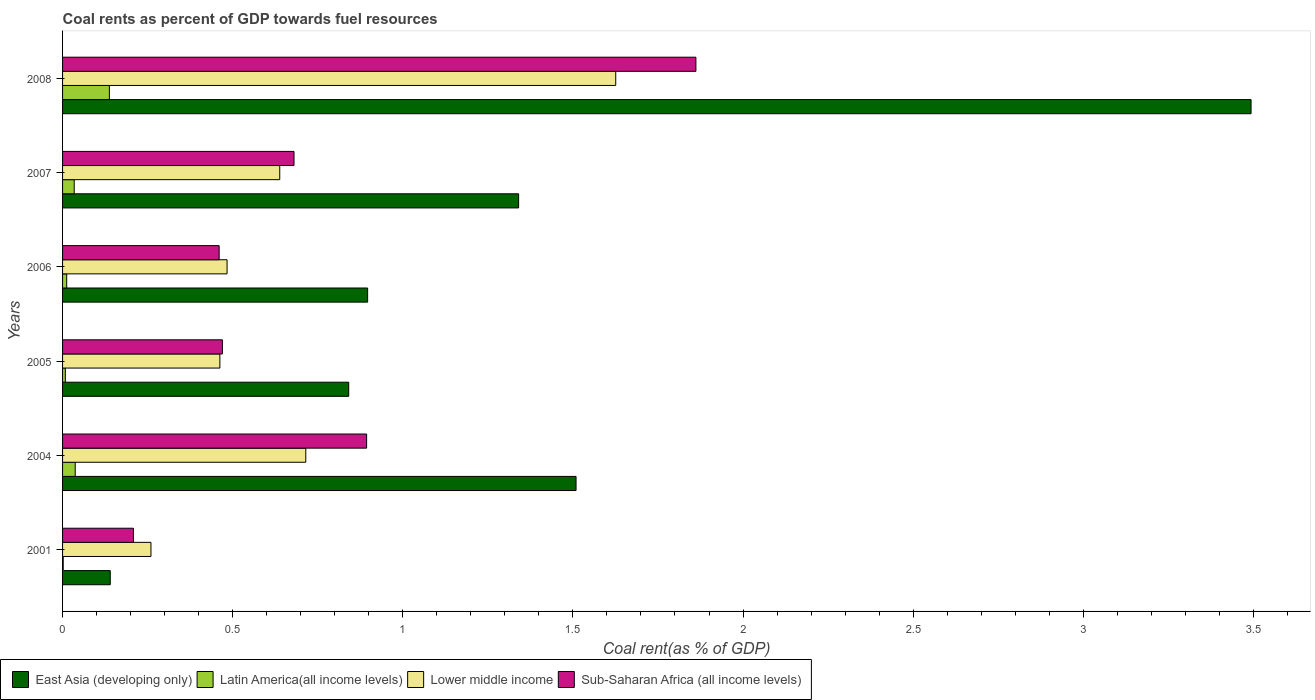How many different coloured bars are there?
Make the answer very short. 4. Are the number of bars per tick equal to the number of legend labels?
Offer a terse response. Yes. How many bars are there on the 4th tick from the bottom?
Offer a very short reply. 4. What is the label of the 3rd group of bars from the top?
Keep it short and to the point. 2006. What is the coal rent in Sub-Saharan Africa (all income levels) in 2008?
Ensure brevity in your answer.  1.86. Across all years, what is the maximum coal rent in East Asia (developing only)?
Keep it short and to the point. 3.49. Across all years, what is the minimum coal rent in Latin America(all income levels)?
Provide a short and direct response. 0. In which year was the coal rent in Lower middle income maximum?
Give a very brief answer. 2008. In which year was the coal rent in East Asia (developing only) minimum?
Offer a terse response. 2001. What is the total coal rent in Lower middle income in the graph?
Make the answer very short. 4.18. What is the difference between the coal rent in Lower middle income in 2004 and that in 2006?
Make the answer very short. 0.23. What is the difference between the coal rent in Lower middle income in 2008 and the coal rent in Latin America(all income levels) in 2007?
Make the answer very short. 1.59. What is the average coal rent in Lower middle income per year?
Offer a very short reply. 0.7. In the year 2006, what is the difference between the coal rent in East Asia (developing only) and coal rent in Latin America(all income levels)?
Give a very brief answer. 0.88. What is the ratio of the coal rent in Latin America(all income levels) in 2004 to that in 2005?
Keep it short and to the point. 4.54. Is the difference between the coal rent in East Asia (developing only) in 2001 and 2006 greater than the difference between the coal rent in Latin America(all income levels) in 2001 and 2006?
Your answer should be compact. No. What is the difference between the highest and the second highest coal rent in East Asia (developing only)?
Your answer should be very brief. 1.98. What is the difference between the highest and the lowest coal rent in Latin America(all income levels)?
Offer a terse response. 0.14. Is it the case that in every year, the sum of the coal rent in Sub-Saharan Africa (all income levels) and coal rent in East Asia (developing only) is greater than the sum of coal rent in Lower middle income and coal rent in Latin America(all income levels)?
Offer a terse response. Yes. What does the 1st bar from the top in 2005 represents?
Provide a short and direct response. Sub-Saharan Africa (all income levels). What does the 2nd bar from the bottom in 2007 represents?
Keep it short and to the point. Latin America(all income levels). How many bars are there?
Offer a terse response. 24. Are all the bars in the graph horizontal?
Your answer should be compact. Yes. Are the values on the major ticks of X-axis written in scientific E-notation?
Ensure brevity in your answer.  No. Does the graph contain any zero values?
Make the answer very short. No. Does the graph contain grids?
Make the answer very short. No. What is the title of the graph?
Give a very brief answer. Coal rents as percent of GDP towards fuel resources. What is the label or title of the X-axis?
Offer a very short reply. Coal rent(as % of GDP). What is the label or title of the Y-axis?
Make the answer very short. Years. What is the Coal rent(as % of GDP) of East Asia (developing only) in 2001?
Offer a very short reply. 0.14. What is the Coal rent(as % of GDP) of Latin America(all income levels) in 2001?
Provide a succinct answer. 0. What is the Coal rent(as % of GDP) in Lower middle income in 2001?
Your answer should be very brief. 0.26. What is the Coal rent(as % of GDP) in Sub-Saharan Africa (all income levels) in 2001?
Your answer should be compact. 0.21. What is the Coal rent(as % of GDP) in East Asia (developing only) in 2004?
Make the answer very short. 1.51. What is the Coal rent(as % of GDP) in Latin America(all income levels) in 2004?
Provide a short and direct response. 0.04. What is the Coal rent(as % of GDP) of Lower middle income in 2004?
Offer a terse response. 0.71. What is the Coal rent(as % of GDP) of Sub-Saharan Africa (all income levels) in 2004?
Your answer should be very brief. 0.89. What is the Coal rent(as % of GDP) in East Asia (developing only) in 2005?
Give a very brief answer. 0.84. What is the Coal rent(as % of GDP) of Latin America(all income levels) in 2005?
Provide a short and direct response. 0.01. What is the Coal rent(as % of GDP) of Lower middle income in 2005?
Give a very brief answer. 0.46. What is the Coal rent(as % of GDP) in Sub-Saharan Africa (all income levels) in 2005?
Your answer should be compact. 0.47. What is the Coal rent(as % of GDP) of East Asia (developing only) in 2006?
Ensure brevity in your answer.  0.9. What is the Coal rent(as % of GDP) in Latin America(all income levels) in 2006?
Offer a very short reply. 0.01. What is the Coal rent(as % of GDP) of Lower middle income in 2006?
Provide a short and direct response. 0.48. What is the Coal rent(as % of GDP) in Sub-Saharan Africa (all income levels) in 2006?
Provide a succinct answer. 0.46. What is the Coal rent(as % of GDP) of East Asia (developing only) in 2007?
Provide a succinct answer. 1.34. What is the Coal rent(as % of GDP) of Latin America(all income levels) in 2007?
Your answer should be very brief. 0.03. What is the Coal rent(as % of GDP) in Lower middle income in 2007?
Provide a short and direct response. 0.64. What is the Coal rent(as % of GDP) of Sub-Saharan Africa (all income levels) in 2007?
Your answer should be very brief. 0.68. What is the Coal rent(as % of GDP) in East Asia (developing only) in 2008?
Ensure brevity in your answer.  3.49. What is the Coal rent(as % of GDP) of Latin America(all income levels) in 2008?
Offer a terse response. 0.14. What is the Coal rent(as % of GDP) of Lower middle income in 2008?
Provide a succinct answer. 1.63. What is the Coal rent(as % of GDP) in Sub-Saharan Africa (all income levels) in 2008?
Your answer should be very brief. 1.86. Across all years, what is the maximum Coal rent(as % of GDP) in East Asia (developing only)?
Offer a terse response. 3.49. Across all years, what is the maximum Coal rent(as % of GDP) in Latin America(all income levels)?
Offer a terse response. 0.14. Across all years, what is the maximum Coal rent(as % of GDP) of Lower middle income?
Give a very brief answer. 1.63. Across all years, what is the maximum Coal rent(as % of GDP) in Sub-Saharan Africa (all income levels)?
Provide a succinct answer. 1.86. Across all years, what is the minimum Coal rent(as % of GDP) of East Asia (developing only)?
Your response must be concise. 0.14. Across all years, what is the minimum Coal rent(as % of GDP) of Latin America(all income levels)?
Offer a very short reply. 0. Across all years, what is the minimum Coal rent(as % of GDP) in Lower middle income?
Give a very brief answer. 0.26. Across all years, what is the minimum Coal rent(as % of GDP) in Sub-Saharan Africa (all income levels)?
Make the answer very short. 0.21. What is the total Coal rent(as % of GDP) of East Asia (developing only) in the graph?
Give a very brief answer. 8.22. What is the total Coal rent(as % of GDP) of Latin America(all income levels) in the graph?
Ensure brevity in your answer.  0.23. What is the total Coal rent(as % of GDP) of Lower middle income in the graph?
Offer a very short reply. 4.18. What is the total Coal rent(as % of GDP) in Sub-Saharan Africa (all income levels) in the graph?
Give a very brief answer. 4.57. What is the difference between the Coal rent(as % of GDP) of East Asia (developing only) in 2001 and that in 2004?
Ensure brevity in your answer.  -1.37. What is the difference between the Coal rent(as % of GDP) of Latin America(all income levels) in 2001 and that in 2004?
Keep it short and to the point. -0.04. What is the difference between the Coal rent(as % of GDP) in Lower middle income in 2001 and that in 2004?
Provide a short and direct response. -0.46. What is the difference between the Coal rent(as % of GDP) of Sub-Saharan Africa (all income levels) in 2001 and that in 2004?
Provide a short and direct response. -0.69. What is the difference between the Coal rent(as % of GDP) in East Asia (developing only) in 2001 and that in 2005?
Make the answer very short. -0.7. What is the difference between the Coal rent(as % of GDP) of Latin America(all income levels) in 2001 and that in 2005?
Ensure brevity in your answer.  -0.01. What is the difference between the Coal rent(as % of GDP) in Lower middle income in 2001 and that in 2005?
Provide a short and direct response. -0.2. What is the difference between the Coal rent(as % of GDP) in Sub-Saharan Africa (all income levels) in 2001 and that in 2005?
Offer a very short reply. -0.26. What is the difference between the Coal rent(as % of GDP) in East Asia (developing only) in 2001 and that in 2006?
Offer a very short reply. -0.76. What is the difference between the Coal rent(as % of GDP) in Latin America(all income levels) in 2001 and that in 2006?
Provide a succinct answer. -0.01. What is the difference between the Coal rent(as % of GDP) of Lower middle income in 2001 and that in 2006?
Offer a terse response. -0.22. What is the difference between the Coal rent(as % of GDP) in Sub-Saharan Africa (all income levels) in 2001 and that in 2006?
Keep it short and to the point. -0.25. What is the difference between the Coal rent(as % of GDP) in East Asia (developing only) in 2001 and that in 2007?
Ensure brevity in your answer.  -1.2. What is the difference between the Coal rent(as % of GDP) in Latin America(all income levels) in 2001 and that in 2007?
Keep it short and to the point. -0.03. What is the difference between the Coal rent(as % of GDP) of Lower middle income in 2001 and that in 2007?
Your answer should be very brief. -0.38. What is the difference between the Coal rent(as % of GDP) of Sub-Saharan Africa (all income levels) in 2001 and that in 2007?
Ensure brevity in your answer.  -0.47. What is the difference between the Coal rent(as % of GDP) in East Asia (developing only) in 2001 and that in 2008?
Ensure brevity in your answer.  -3.35. What is the difference between the Coal rent(as % of GDP) in Latin America(all income levels) in 2001 and that in 2008?
Provide a short and direct response. -0.14. What is the difference between the Coal rent(as % of GDP) of Lower middle income in 2001 and that in 2008?
Ensure brevity in your answer.  -1.37. What is the difference between the Coal rent(as % of GDP) of Sub-Saharan Africa (all income levels) in 2001 and that in 2008?
Your response must be concise. -1.65. What is the difference between the Coal rent(as % of GDP) of East Asia (developing only) in 2004 and that in 2005?
Your answer should be compact. 0.67. What is the difference between the Coal rent(as % of GDP) in Latin America(all income levels) in 2004 and that in 2005?
Offer a very short reply. 0.03. What is the difference between the Coal rent(as % of GDP) of Lower middle income in 2004 and that in 2005?
Offer a terse response. 0.25. What is the difference between the Coal rent(as % of GDP) of Sub-Saharan Africa (all income levels) in 2004 and that in 2005?
Ensure brevity in your answer.  0.42. What is the difference between the Coal rent(as % of GDP) of East Asia (developing only) in 2004 and that in 2006?
Make the answer very short. 0.61. What is the difference between the Coal rent(as % of GDP) of Latin America(all income levels) in 2004 and that in 2006?
Make the answer very short. 0.03. What is the difference between the Coal rent(as % of GDP) of Lower middle income in 2004 and that in 2006?
Provide a short and direct response. 0.23. What is the difference between the Coal rent(as % of GDP) of Sub-Saharan Africa (all income levels) in 2004 and that in 2006?
Your response must be concise. 0.43. What is the difference between the Coal rent(as % of GDP) of East Asia (developing only) in 2004 and that in 2007?
Your answer should be very brief. 0.17. What is the difference between the Coal rent(as % of GDP) in Latin America(all income levels) in 2004 and that in 2007?
Your answer should be very brief. 0. What is the difference between the Coal rent(as % of GDP) in Lower middle income in 2004 and that in 2007?
Make the answer very short. 0.08. What is the difference between the Coal rent(as % of GDP) of Sub-Saharan Africa (all income levels) in 2004 and that in 2007?
Your answer should be compact. 0.21. What is the difference between the Coal rent(as % of GDP) in East Asia (developing only) in 2004 and that in 2008?
Keep it short and to the point. -1.98. What is the difference between the Coal rent(as % of GDP) of Latin America(all income levels) in 2004 and that in 2008?
Give a very brief answer. -0.1. What is the difference between the Coal rent(as % of GDP) in Lower middle income in 2004 and that in 2008?
Your response must be concise. -0.91. What is the difference between the Coal rent(as % of GDP) of Sub-Saharan Africa (all income levels) in 2004 and that in 2008?
Offer a terse response. -0.97. What is the difference between the Coal rent(as % of GDP) in East Asia (developing only) in 2005 and that in 2006?
Your answer should be very brief. -0.06. What is the difference between the Coal rent(as % of GDP) in Latin America(all income levels) in 2005 and that in 2006?
Offer a very short reply. -0. What is the difference between the Coal rent(as % of GDP) in Lower middle income in 2005 and that in 2006?
Your answer should be very brief. -0.02. What is the difference between the Coal rent(as % of GDP) of Sub-Saharan Africa (all income levels) in 2005 and that in 2006?
Your answer should be compact. 0.01. What is the difference between the Coal rent(as % of GDP) in East Asia (developing only) in 2005 and that in 2007?
Give a very brief answer. -0.5. What is the difference between the Coal rent(as % of GDP) in Latin America(all income levels) in 2005 and that in 2007?
Make the answer very short. -0.03. What is the difference between the Coal rent(as % of GDP) of Lower middle income in 2005 and that in 2007?
Keep it short and to the point. -0.18. What is the difference between the Coal rent(as % of GDP) of Sub-Saharan Africa (all income levels) in 2005 and that in 2007?
Keep it short and to the point. -0.21. What is the difference between the Coal rent(as % of GDP) in East Asia (developing only) in 2005 and that in 2008?
Make the answer very short. -2.65. What is the difference between the Coal rent(as % of GDP) in Latin America(all income levels) in 2005 and that in 2008?
Make the answer very short. -0.13. What is the difference between the Coal rent(as % of GDP) in Lower middle income in 2005 and that in 2008?
Keep it short and to the point. -1.16. What is the difference between the Coal rent(as % of GDP) in Sub-Saharan Africa (all income levels) in 2005 and that in 2008?
Your response must be concise. -1.39. What is the difference between the Coal rent(as % of GDP) of East Asia (developing only) in 2006 and that in 2007?
Offer a terse response. -0.44. What is the difference between the Coal rent(as % of GDP) in Latin America(all income levels) in 2006 and that in 2007?
Keep it short and to the point. -0.02. What is the difference between the Coal rent(as % of GDP) in Lower middle income in 2006 and that in 2007?
Your answer should be very brief. -0.15. What is the difference between the Coal rent(as % of GDP) of Sub-Saharan Africa (all income levels) in 2006 and that in 2007?
Your answer should be very brief. -0.22. What is the difference between the Coal rent(as % of GDP) of East Asia (developing only) in 2006 and that in 2008?
Provide a succinct answer. -2.6. What is the difference between the Coal rent(as % of GDP) in Latin America(all income levels) in 2006 and that in 2008?
Offer a terse response. -0.13. What is the difference between the Coal rent(as % of GDP) of Lower middle income in 2006 and that in 2008?
Make the answer very short. -1.14. What is the difference between the Coal rent(as % of GDP) of Sub-Saharan Africa (all income levels) in 2006 and that in 2008?
Give a very brief answer. -1.4. What is the difference between the Coal rent(as % of GDP) in East Asia (developing only) in 2007 and that in 2008?
Your response must be concise. -2.15. What is the difference between the Coal rent(as % of GDP) of Latin America(all income levels) in 2007 and that in 2008?
Provide a succinct answer. -0.1. What is the difference between the Coal rent(as % of GDP) in Lower middle income in 2007 and that in 2008?
Give a very brief answer. -0.99. What is the difference between the Coal rent(as % of GDP) of Sub-Saharan Africa (all income levels) in 2007 and that in 2008?
Ensure brevity in your answer.  -1.18. What is the difference between the Coal rent(as % of GDP) in East Asia (developing only) in 2001 and the Coal rent(as % of GDP) in Latin America(all income levels) in 2004?
Your answer should be very brief. 0.1. What is the difference between the Coal rent(as % of GDP) in East Asia (developing only) in 2001 and the Coal rent(as % of GDP) in Lower middle income in 2004?
Your response must be concise. -0.57. What is the difference between the Coal rent(as % of GDP) of East Asia (developing only) in 2001 and the Coal rent(as % of GDP) of Sub-Saharan Africa (all income levels) in 2004?
Your answer should be compact. -0.75. What is the difference between the Coal rent(as % of GDP) of Latin America(all income levels) in 2001 and the Coal rent(as % of GDP) of Lower middle income in 2004?
Keep it short and to the point. -0.71. What is the difference between the Coal rent(as % of GDP) of Latin America(all income levels) in 2001 and the Coal rent(as % of GDP) of Sub-Saharan Africa (all income levels) in 2004?
Your answer should be compact. -0.89. What is the difference between the Coal rent(as % of GDP) of Lower middle income in 2001 and the Coal rent(as % of GDP) of Sub-Saharan Africa (all income levels) in 2004?
Your response must be concise. -0.63. What is the difference between the Coal rent(as % of GDP) of East Asia (developing only) in 2001 and the Coal rent(as % of GDP) of Latin America(all income levels) in 2005?
Offer a very short reply. 0.13. What is the difference between the Coal rent(as % of GDP) of East Asia (developing only) in 2001 and the Coal rent(as % of GDP) of Lower middle income in 2005?
Your answer should be very brief. -0.32. What is the difference between the Coal rent(as % of GDP) of East Asia (developing only) in 2001 and the Coal rent(as % of GDP) of Sub-Saharan Africa (all income levels) in 2005?
Offer a terse response. -0.33. What is the difference between the Coal rent(as % of GDP) of Latin America(all income levels) in 2001 and the Coal rent(as % of GDP) of Lower middle income in 2005?
Provide a short and direct response. -0.46. What is the difference between the Coal rent(as % of GDP) in Latin America(all income levels) in 2001 and the Coal rent(as % of GDP) in Sub-Saharan Africa (all income levels) in 2005?
Offer a very short reply. -0.47. What is the difference between the Coal rent(as % of GDP) in Lower middle income in 2001 and the Coal rent(as % of GDP) in Sub-Saharan Africa (all income levels) in 2005?
Your answer should be compact. -0.21. What is the difference between the Coal rent(as % of GDP) in East Asia (developing only) in 2001 and the Coal rent(as % of GDP) in Latin America(all income levels) in 2006?
Ensure brevity in your answer.  0.13. What is the difference between the Coal rent(as % of GDP) in East Asia (developing only) in 2001 and the Coal rent(as % of GDP) in Lower middle income in 2006?
Your answer should be very brief. -0.34. What is the difference between the Coal rent(as % of GDP) in East Asia (developing only) in 2001 and the Coal rent(as % of GDP) in Sub-Saharan Africa (all income levels) in 2006?
Make the answer very short. -0.32. What is the difference between the Coal rent(as % of GDP) of Latin America(all income levels) in 2001 and the Coal rent(as % of GDP) of Lower middle income in 2006?
Your response must be concise. -0.48. What is the difference between the Coal rent(as % of GDP) of Latin America(all income levels) in 2001 and the Coal rent(as % of GDP) of Sub-Saharan Africa (all income levels) in 2006?
Provide a short and direct response. -0.46. What is the difference between the Coal rent(as % of GDP) in Lower middle income in 2001 and the Coal rent(as % of GDP) in Sub-Saharan Africa (all income levels) in 2006?
Offer a very short reply. -0.2. What is the difference between the Coal rent(as % of GDP) of East Asia (developing only) in 2001 and the Coal rent(as % of GDP) of Latin America(all income levels) in 2007?
Offer a very short reply. 0.11. What is the difference between the Coal rent(as % of GDP) of East Asia (developing only) in 2001 and the Coal rent(as % of GDP) of Lower middle income in 2007?
Your answer should be very brief. -0.5. What is the difference between the Coal rent(as % of GDP) in East Asia (developing only) in 2001 and the Coal rent(as % of GDP) in Sub-Saharan Africa (all income levels) in 2007?
Give a very brief answer. -0.54. What is the difference between the Coal rent(as % of GDP) in Latin America(all income levels) in 2001 and the Coal rent(as % of GDP) in Lower middle income in 2007?
Offer a terse response. -0.64. What is the difference between the Coal rent(as % of GDP) of Latin America(all income levels) in 2001 and the Coal rent(as % of GDP) of Sub-Saharan Africa (all income levels) in 2007?
Make the answer very short. -0.68. What is the difference between the Coal rent(as % of GDP) of Lower middle income in 2001 and the Coal rent(as % of GDP) of Sub-Saharan Africa (all income levels) in 2007?
Offer a terse response. -0.42. What is the difference between the Coal rent(as % of GDP) in East Asia (developing only) in 2001 and the Coal rent(as % of GDP) in Latin America(all income levels) in 2008?
Provide a succinct answer. 0. What is the difference between the Coal rent(as % of GDP) of East Asia (developing only) in 2001 and the Coal rent(as % of GDP) of Lower middle income in 2008?
Your answer should be very brief. -1.49. What is the difference between the Coal rent(as % of GDP) in East Asia (developing only) in 2001 and the Coal rent(as % of GDP) in Sub-Saharan Africa (all income levels) in 2008?
Provide a succinct answer. -1.72. What is the difference between the Coal rent(as % of GDP) of Latin America(all income levels) in 2001 and the Coal rent(as % of GDP) of Lower middle income in 2008?
Provide a succinct answer. -1.62. What is the difference between the Coal rent(as % of GDP) in Latin America(all income levels) in 2001 and the Coal rent(as % of GDP) in Sub-Saharan Africa (all income levels) in 2008?
Keep it short and to the point. -1.86. What is the difference between the Coal rent(as % of GDP) of Lower middle income in 2001 and the Coal rent(as % of GDP) of Sub-Saharan Africa (all income levels) in 2008?
Your answer should be compact. -1.6. What is the difference between the Coal rent(as % of GDP) of East Asia (developing only) in 2004 and the Coal rent(as % of GDP) of Latin America(all income levels) in 2005?
Offer a terse response. 1.5. What is the difference between the Coal rent(as % of GDP) in East Asia (developing only) in 2004 and the Coal rent(as % of GDP) in Lower middle income in 2005?
Your response must be concise. 1.05. What is the difference between the Coal rent(as % of GDP) of East Asia (developing only) in 2004 and the Coal rent(as % of GDP) of Sub-Saharan Africa (all income levels) in 2005?
Give a very brief answer. 1.04. What is the difference between the Coal rent(as % of GDP) in Latin America(all income levels) in 2004 and the Coal rent(as % of GDP) in Lower middle income in 2005?
Ensure brevity in your answer.  -0.43. What is the difference between the Coal rent(as % of GDP) of Latin America(all income levels) in 2004 and the Coal rent(as % of GDP) of Sub-Saharan Africa (all income levels) in 2005?
Your response must be concise. -0.43. What is the difference between the Coal rent(as % of GDP) of Lower middle income in 2004 and the Coal rent(as % of GDP) of Sub-Saharan Africa (all income levels) in 2005?
Your answer should be compact. 0.25. What is the difference between the Coal rent(as % of GDP) in East Asia (developing only) in 2004 and the Coal rent(as % of GDP) in Latin America(all income levels) in 2006?
Keep it short and to the point. 1.5. What is the difference between the Coal rent(as % of GDP) of East Asia (developing only) in 2004 and the Coal rent(as % of GDP) of Lower middle income in 2006?
Keep it short and to the point. 1.03. What is the difference between the Coal rent(as % of GDP) in East Asia (developing only) in 2004 and the Coal rent(as % of GDP) in Sub-Saharan Africa (all income levels) in 2006?
Keep it short and to the point. 1.05. What is the difference between the Coal rent(as % of GDP) in Latin America(all income levels) in 2004 and the Coal rent(as % of GDP) in Lower middle income in 2006?
Provide a short and direct response. -0.45. What is the difference between the Coal rent(as % of GDP) of Latin America(all income levels) in 2004 and the Coal rent(as % of GDP) of Sub-Saharan Africa (all income levels) in 2006?
Ensure brevity in your answer.  -0.42. What is the difference between the Coal rent(as % of GDP) of Lower middle income in 2004 and the Coal rent(as % of GDP) of Sub-Saharan Africa (all income levels) in 2006?
Give a very brief answer. 0.25. What is the difference between the Coal rent(as % of GDP) in East Asia (developing only) in 2004 and the Coal rent(as % of GDP) in Latin America(all income levels) in 2007?
Ensure brevity in your answer.  1.48. What is the difference between the Coal rent(as % of GDP) in East Asia (developing only) in 2004 and the Coal rent(as % of GDP) in Lower middle income in 2007?
Provide a short and direct response. 0.87. What is the difference between the Coal rent(as % of GDP) in East Asia (developing only) in 2004 and the Coal rent(as % of GDP) in Sub-Saharan Africa (all income levels) in 2007?
Offer a terse response. 0.83. What is the difference between the Coal rent(as % of GDP) in Latin America(all income levels) in 2004 and the Coal rent(as % of GDP) in Lower middle income in 2007?
Offer a terse response. -0.6. What is the difference between the Coal rent(as % of GDP) of Latin America(all income levels) in 2004 and the Coal rent(as % of GDP) of Sub-Saharan Africa (all income levels) in 2007?
Keep it short and to the point. -0.64. What is the difference between the Coal rent(as % of GDP) of Lower middle income in 2004 and the Coal rent(as % of GDP) of Sub-Saharan Africa (all income levels) in 2007?
Make the answer very short. 0.03. What is the difference between the Coal rent(as % of GDP) in East Asia (developing only) in 2004 and the Coal rent(as % of GDP) in Latin America(all income levels) in 2008?
Provide a succinct answer. 1.37. What is the difference between the Coal rent(as % of GDP) in East Asia (developing only) in 2004 and the Coal rent(as % of GDP) in Lower middle income in 2008?
Make the answer very short. -0.12. What is the difference between the Coal rent(as % of GDP) in East Asia (developing only) in 2004 and the Coal rent(as % of GDP) in Sub-Saharan Africa (all income levels) in 2008?
Your answer should be compact. -0.35. What is the difference between the Coal rent(as % of GDP) in Latin America(all income levels) in 2004 and the Coal rent(as % of GDP) in Lower middle income in 2008?
Your answer should be compact. -1.59. What is the difference between the Coal rent(as % of GDP) of Latin America(all income levels) in 2004 and the Coal rent(as % of GDP) of Sub-Saharan Africa (all income levels) in 2008?
Offer a terse response. -1.82. What is the difference between the Coal rent(as % of GDP) of Lower middle income in 2004 and the Coal rent(as % of GDP) of Sub-Saharan Africa (all income levels) in 2008?
Your response must be concise. -1.15. What is the difference between the Coal rent(as % of GDP) in East Asia (developing only) in 2005 and the Coal rent(as % of GDP) in Latin America(all income levels) in 2006?
Your response must be concise. 0.83. What is the difference between the Coal rent(as % of GDP) of East Asia (developing only) in 2005 and the Coal rent(as % of GDP) of Lower middle income in 2006?
Give a very brief answer. 0.36. What is the difference between the Coal rent(as % of GDP) in East Asia (developing only) in 2005 and the Coal rent(as % of GDP) in Sub-Saharan Africa (all income levels) in 2006?
Give a very brief answer. 0.38. What is the difference between the Coal rent(as % of GDP) of Latin America(all income levels) in 2005 and the Coal rent(as % of GDP) of Lower middle income in 2006?
Provide a succinct answer. -0.48. What is the difference between the Coal rent(as % of GDP) of Latin America(all income levels) in 2005 and the Coal rent(as % of GDP) of Sub-Saharan Africa (all income levels) in 2006?
Provide a succinct answer. -0.45. What is the difference between the Coal rent(as % of GDP) of Lower middle income in 2005 and the Coal rent(as % of GDP) of Sub-Saharan Africa (all income levels) in 2006?
Keep it short and to the point. 0. What is the difference between the Coal rent(as % of GDP) in East Asia (developing only) in 2005 and the Coal rent(as % of GDP) in Latin America(all income levels) in 2007?
Your response must be concise. 0.81. What is the difference between the Coal rent(as % of GDP) of East Asia (developing only) in 2005 and the Coal rent(as % of GDP) of Lower middle income in 2007?
Make the answer very short. 0.2. What is the difference between the Coal rent(as % of GDP) of East Asia (developing only) in 2005 and the Coal rent(as % of GDP) of Sub-Saharan Africa (all income levels) in 2007?
Ensure brevity in your answer.  0.16. What is the difference between the Coal rent(as % of GDP) of Latin America(all income levels) in 2005 and the Coal rent(as % of GDP) of Lower middle income in 2007?
Your response must be concise. -0.63. What is the difference between the Coal rent(as % of GDP) of Latin America(all income levels) in 2005 and the Coal rent(as % of GDP) of Sub-Saharan Africa (all income levels) in 2007?
Keep it short and to the point. -0.67. What is the difference between the Coal rent(as % of GDP) in Lower middle income in 2005 and the Coal rent(as % of GDP) in Sub-Saharan Africa (all income levels) in 2007?
Provide a short and direct response. -0.22. What is the difference between the Coal rent(as % of GDP) of East Asia (developing only) in 2005 and the Coal rent(as % of GDP) of Latin America(all income levels) in 2008?
Provide a short and direct response. 0.7. What is the difference between the Coal rent(as % of GDP) in East Asia (developing only) in 2005 and the Coal rent(as % of GDP) in Lower middle income in 2008?
Your response must be concise. -0.78. What is the difference between the Coal rent(as % of GDP) of East Asia (developing only) in 2005 and the Coal rent(as % of GDP) of Sub-Saharan Africa (all income levels) in 2008?
Ensure brevity in your answer.  -1.02. What is the difference between the Coal rent(as % of GDP) in Latin America(all income levels) in 2005 and the Coal rent(as % of GDP) in Lower middle income in 2008?
Keep it short and to the point. -1.62. What is the difference between the Coal rent(as % of GDP) in Latin America(all income levels) in 2005 and the Coal rent(as % of GDP) in Sub-Saharan Africa (all income levels) in 2008?
Your answer should be very brief. -1.85. What is the difference between the Coal rent(as % of GDP) in Lower middle income in 2005 and the Coal rent(as % of GDP) in Sub-Saharan Africa (all income levels) in 2008?
Keep it short and to the point. -1.4. What is the difference between the Coal rent(as % of GDP) in East Asia (developing only) in 2006 and the Coal rent(as % of GDP) in Latin America(all income levels) in 2007?
Give a very brief answer. 0.86. What is the difference between the Coal rent(as % of GDP) of East Asia (developing only) in 2006 and the Coal rent(as % of GDP) of Lower middle income in 2007?
Make the answer very short. 0.26. What is the difference between the Coal rent(as % of GDP) of East Asia (developing only) in 2006 and the Coal rent(as % of GDP) of Sub-Saharan Africa (all income levels) in 2007?
Provide a short and direct response. 0.22. What is the difference between the Coal rent(as % of GDP) in Latin America(all income levels) in 2006 and the Coal rent(as % of GDP) in Lower middle income in 2007?
Make the answer very short. -0.63. What is the difference between the Coal rent(as % of GDP) of Latin America(all income levels) in 2006 and the Coal rent(as % of GDP) of Sub-Saharan Africa (all income levels) in 2007?
Give a very brief answer. -0.67. What is the difference between the Coal rent(as % of GDP) of Lower middle income in 2006 and the Coal rent(as % of GDP) of Sub-Saharan Africa (all income levels) in 2007?
Offer a terse response. -0.2. What is the difference between the Coal rent(as % of GDP) in East Asia (developing only) in 2006 and the Coal rent(as % of GDP) in Latin America(all income levels) in 2008?
Give a very brief answer. 0.76. What is the difference between the Coal rent(as % of GDP) of East Asia (developing only) in 2006 and the Coal rent(as % of GDP) of Lower middle income in 2008?
Your answer should be very brief. -0.73. What is the difference between the Coal rent(as % of GDP) of East Asia (developing only) in 2006 and the Coal rent(as % of GDP) of Sub-Saharan Africa (all income levels) in 2008?
Your answer should be very brief. -0.96. What is the difference between the Coal rent(as % of GDP) in Latin America(all income levels) in 2006 and the Coal rent(as % of GDP) in Lower middle income in 2008?
Your answer should be compact. -1.61. What is the difference between the Coal rent(as % of GDP) in Latin America(all income levels) in 2006 and the Coal rent(as % of GDP) in Sub-Saharan Africa (all income levels) in 2008?
Provide a short and direct response. -1.85. What is the difference between the Coal rent(as % of GDP) of Lower middle income in 2006 and the Coal rent(as % of GDP) of Sub-Saharan Africa (all income levels) in 2008?
Your answer should be very brief. -1.38. What is the difference between the Coal rent(as % of GDP) in East Asia (developing only) in 2007 and the Coal rent(as % of GDP) in Latin America(all income levels) in 2008?
Make the answer very short. 1.2. What is the difference between the Coal rent(as % of GDP) of East Asia (developing only) in 2007 and the Coal rent(as % of GDP) of Lower middle income in 2008?
Your answer should be compact. -0.29. What is the difference between the Coal rent(as % of GDP) in East Asia (developing only) in 2007 and the Coal rent(as % of GDP) in Sub-Saharan Africa (all income levels) in 2008?
Offer a very short reply. -0.52. What is the difference between the Coal rent(as % of GDP) of Latin America(all income levels) in 2007 and the Coal rent(as % of GDP) of Lower middle income in 2008?
Your answer should be compact. -1.59. What is the difference between the Coal rent(as % of GDP) in Latin America(all income levels) in 2007 and the Coal rent(as % of GDP) in Sub-Saharan Africa (all income levels) in 2008?
Provide a short and direct response. -1.83. What is the difference between the Coal rent(as % of GDP) of Lower middle income in 2007 and the Coal rent(as % of GDP) of Sub-Saharan Africa (all income levels) in 2008?
Offer a terse response. -1.22. What is the average Coal rent(as % of GDP) in East Asia (developing only) per year?
Give a very brief answer. 1.37. What is the average Coal rent(as % of GDP) in Latin America(all income levels) per year?
Make the answer very short. 0.04. What is the average Coal rent(as % of GDP) in Lower middle income per year?
Provide a succinct answer. 0.7. What is the average Coal rent(as % of GDP) of Sub-Saharan Africa (all income levels) per year?
Offer a very short reply. 0.76. In the year 2001, what is the difference between the Coal rent(as % of GDP) of East Asia (developing only) and Coal rent(as % of GDP) of Latin America(all income levels)?
Provide a short and direct response. 0.14. In the year 2001, what is the difference between the Coal rent(as % of GDP) of East Asia (developing only) and Coal rent(as % of GDP) of Lower middle income?
Offer a very short reply. -0.12. In the year 2001, what is the difference between the Coal rent(as % of GDP) of East Asia (developing only) and Coal rent(as % of GDP) of Sub-Saharan Africa (all income levels)?
Your answer should be very brief. -0.07. In the year 2001, what is the difference between the Coal rent(as % of GDP) in Latin America(all income levels) and Coal rent(as % of GDP) in Lower middle income?
Make the answer very short. -0.26. In the year 2001, what is the difference between the Coal rent(as % of GDP) in Latin America(all income levels) and Coal rent(as % of GDP) in Sub-Saharan Africa (all income levels)?
Ensure brevity in your answer.  -0.21. In the year 2001, what is the difference between the Coal rent(as % of GDP) of Lower middle income and Coal rent(as % of GDP) of Sub-Saharan Africa (all income levels)?
Keep it short and to the point. 0.05. In the year 2004, what is the difference between the Coal rent(as % of GDP) of East Asia (developing only) and Coal rent(as % of GDP) of Latin America(all income levels)?
Provide a short and direct response. 1.47. In the year 2004, what is the difference between the Coal rent(as % of GDP) of East Asia (developing only) and Coal rent(as % of GDP) of Lower middle income?
Provide a succinct answer. 0.79. In the year 2004, what is the difference between the Coal rent(as % of GDP) of East Asia (developing only) and Coal rent(as % of GDP) of Sub-Saharan Africa (all income levels)?
Provide a succinct answer. 0.62. In the year 2004, what is the difference between the Coal rent(as % of GDP) of Latin America(all income levels) and Coal rent(as % of GDP) of Lower middle income?
Make the answer very short. -0.68. In the year 2004, what is the difference between the Coal rent(as % of GDP) in Latin America(all income levels) and Coal rent(as % of GDP) in Sub-Saharan Africa (all income levels)?
Offer a terse response. -0.86. In the year 2004, what is the difference between the Coal rent(as % of GDP) of Lower middle income and Coal rent(as % of GDP) of Sub-Saharan Africa (all income levels)?
Your answer should be very brief. -0.18. In the year 2005, what is the difference between the Coal rent(as % of GDP) in East Asia (developing only) and Coal rent(as % of GDP) in Latin America(all income levels)?
Offer a very short reply. 0.83. In the year 2005, what is the difference between the Coal rent(as % of GDP) in East Asia (developing only) and Coal rent(as % of GDP) in Lower middle income?
Give a very brief answer. 0.38. In the year 2005, what is the difference between the Coal rent(as % of GDP) of East Asia (developing only) and Coal rent(as % of GDP) of Sub-Saharan Africa (all income levels)?
Provide a succinct answer. 0.37. In the year 2005, what is the difference between the Coal rent(as % of GDP) of Latin America(all income levels) and Coal rent(as % of GDP) of Lower middle income?
Give a very brief answer. -0.45. In the year 2005, what is the difference between the Coal rent(as % of GDP) in Latin America(all income levels) and Coal rent(as % of GDP) in Sub-Saharan Africa (all income levels)?
Give a very brief answer. -0.46. In the year 2005, what is the difference between the Coal rent(as % of GDP) of Lower middle income and Coal rent(as % of GDP) of Sub-Saharan Africa (all income levels)?
Your answer should be very brief. -0.01. In the year 2006, what is the difference between the Coal rent(as % of GDP) in East Asia (developing only) and Coal rent(as % of GDP) in Latin America(all income levels)?
Make the answer very short. 0.88. In the year 2006, what is the difference between the Coal rent(as % of GDP) of East Asia (developing only) and Coal rent(as % of GDP) of Lower middle income?
Your answer should be compact. 0.41. In the year 2006, what is the difference between the Coal rent(as % of GDP) in East Asia (developing only) and Coal rent(as % of GDP) in Sub-Saharan Africa (all income levels)?
Ensure brevity in your answer.  0.44. In the year 2006, what is the difference between the Coal rent(as % of GDP) of Latin America(all income levels) and Coal rent(as % of GDP) of Lower middle income?
Ensure brevity in your answer.  -0.47. In the year 2006, what is the difference between the Coal rent(as % of GDP) of Latin America(all income levels) and Coal rent(as % of GDP) of Sub-Saharan Africa (all income levels)?
Your answer should be compact. -0.45. In the year 2006, what is the difference between the Coal rent(as % of GDP) in Lower middle income and Coal rent(as % of GDP) in Sub-Saharan Africa (all income levels)?
Ensure brevity in your answer.  0.02. In the year 2007, what is the difference between the Coal rent(as % of GDP) in East Asia (developing only) and Coal rent(as % of GDP) in Latin America(all income levels)?
Offer a very short reply. 1.31. In the year 2007, what is the difference between the Coal rent(as % of GDP) of East Asia (developing only) and Coal rent(as % of GDP) of Lower middle income?
Your answer should be compact. 0.7. In the year 2007, what is the difference between the Coal rent(as % of GDP) in East Asia (developing only) and Coal rent(as % of GDP) in Sub-Saharan Africa (all income levels)?
Make the answer very short. 0.66. In the year 2007, what is the difference between the Coal rent(as % of GDP) of Latin America(all income levels) and Coal rent(as % of GDP) of Lower middle income?
Make the answer very short. -0.6. In the year 2007, what is the difference between the Coal rent(as % of GDP) of Latin America(all income levels) and Coal rent(as % of GDP) of Sub-Saharan Africa (all income levels)?
Make the answer very short. -0.65. In the year 2007, what is the difference between the Coal rent(as % of GDP) of Lower middle income and Coal rent(as % of GDP) of Sub-Saharan Africa (all income levels)?
Your response must be concise. -0.04. In the year 2008, what is the difference between the Coal rent(as % of GDP) in East Asia (developing only) and Coal rent(as % of GDP) in Latin America(all income levels)?
Provide a short and direct response. 3.36. In the year 2008, what is the difference between the Coal rent(as % of GDP) of East Asia (developing only) and Coal rent(as % of GDP) of Lower middle income?
Your answer should be compact. 1.87. In the year 2008, what is the difference between the Coal rent(as % of GDP) of East Asia (developing only) and Coal rent(as % of GDP) of Sub-Saharan Africa (all income levels)?
Give a very brief answer. 1.63. In the year 2008, what is the difference between the Coal rent(as % of GDP) in Latin America(all income levels) and Coal rent(as % of GDP) in Lower middle income?
Your response must be concise. -1.49. In the year 2008, what is the difference between the Coal rent(as % of GDP) of Latin America(all income levels) and Coal rent(as % of GDP) of Sub-Saharan Africa (all income levels)?
Make the answer very short. -1.72. In the year 2008, what is the difference between the Coal rent(as % of GDP) of Lower middle income and Coal rent(as % of GDP) of Sub-Saharan Africa (all income levels)?
Provide a succinct answer. -0.24. What is the ratio of the Coal rent(as % of GDP) in East Asia (developing only) in 2001 to that in 2004?
Offer a very short reply. 0.09. What is the ratio of the Coal rent(as % of GDP) of Latin America(all income levels) in 2001 to that in 2004?
Your answer should be compact. 0.05. What is the ratio of the Coal rent(as % of GDP) of Lower middle income in 2001 to that in 2004?
Provide a short and direct response. 0.36. What is the ratio of the Coal rent(as % of GDP) of Sub-Saharan Africa (all income levels) in 2001 to that in 2004?
Ensure brevity in your answer.  0.23. What is the ratio of the Coal rent(as % of GDP) of East Asia (developing only) in 2001 to that in 2005?
Provide a succinct answer. 0.17. What is the ratio of the Coal rent(as % of GDP) in Latin America(all income levels) in 2001 to that in 2005?
Your response must be concise. 0.23. What is the ratio of the Coal rent(as % of GDP) in Lower middle income in 2001 to that in 2005?
Ensure brevity in your answer.  0.56. What is the ratio of the Coal rent(as % of GDP) in Sub-Saharan Africa (all income levels) in 2001 to that in 2005?
Offer a terse response. 0.44. What is the ratio of the Coal rent(as % of GDP) of East Asia (developing only) in 2001 to that in 2006?
Provide a short and direct response. 0.16. What is the ratio of the Coal rent(as % of GDP) in Latin America(all income levels) in 2001 to that in 2006?
Keep it short and to the point. 0.16. What is the ratio of the Coal rent(as % of GDP) of Lower middle income in 2001 to that in 2006?
Your response must be concise. 0.54. What is the ratio of the Coal rent(as % of GDP) of Sub-Saharan Africa (all income levels) in 2001 to that in 2006?
Provide a succinct answer. 0.45. What is the ratio of the Coal rent(as % of GDP) of East Asia (developing only) in 2001 to that in 2007?
Give a very brief answer. 0.1. What is the ratio of the Coal rent(as % of GDP) of Latin America(all income levels) in 2001 to that in 2007?
Your answer should be very brief. 0.06. What is the ratio of the Coal rent(as % of GDP) in Lower middle income in 2001 to that in 2007?
Make the answer very short. 0.41. What is the ratio of the Coal rent(as % of GDP) of Sub-Saharan Africa (all income levels) in 2001 to that in 2007?
Ensure brevity in your answer.  0.31. What is the ratio of the Coal rent(as % of GDP) in East Asia (developing only) in 2001 to that in 2008?
Ensure brevity in your answer.  0.04. What is the ratio of the Coal rent(as % of GDP) in Latin America(all income levels) in 2001 to that in 2008?
Offer a terse response. 0.01. What is the ratio of the Coal rent(as % of GDP) of Lower middle income in 2001 to that in 2008?
Provide a succinct answer. 0.16. What is the ratio of the Coal rent(as % of GDP) in Sub-Saharan Africa (all income levels) in 2001 to that in 2008?
Give a very brief answer. 0.11. What is the ratio of the Coal rent(as % of GDP) of East Asia (developing only) in 2004 to that in 2005?
Give a very brief answer. 1.79. What is the ratio of the Coal rent(as % of GDP) of Latin America(all income levels) in 2004 to that in 2005?
Your response must be concise. 4.54. What is the ratio of the Coal rent(as % of GDP) in Lower middle income in 2004 to that in 2005?
Your answer should be compact. 1.55. What is the ratio of the Coal rent(as % of GDP) in Sub-Saharan Africa (all income levels) in 2004 to that in 2005?
Provide a short and direct response. 1.9. What is the ratio of the Coal rent(as % of GDP) in East Asia (developing only) in 2004 to that in 2006?
Your answer should be compact. 1.68. What is the ratio of the Coal rent(as % of GDP) of Latin America(all income levels) in 2004 to that in 2006?
Give a very brief answer. 3.06. What is the ratio of the Coal rent(as % of GDP) in Lower middle income in 2004 to that in 2006?
Your answer should be very brief. 1.48. What is the ratio of the Coal rent(as % of GDP) in Sub-Saharan Africa (all income levels) in 2004 to that in 2006?
Your response must be concise. 1.94. What is the ratio of the Coal rent(as % of GDP) in East Asia (developing only) in 2004 to that in 2007?
Ensure brevity in your answer.  1.13. What is the ratio of the Coal rent(as % of GDP) in Latin America(all income levels) in 2004 to that in 2007?
Your answer should be very brief. 1.09. What is the ratio of the Coal rent(as % of GDP) of Lower middle income in 2004 to that in 2007?
Your answer should be very brief. 1.12. What is the ratio of the Coal rent(as % of GDP) in Sub-Saharan Africa (all income levels) in 2004 to that in 2007?
Your response must be concise. 1.31. What is the ratio of the Coal rent(as % of GDP) of East Asia (developing only) in 2004 to that in 2008?
Your response must be concise. 0.43. What is the ratio of the Coal rent(as % of GDP) of Latin America(all income levels) in 2004 to that in 2008?
Ensure brevity in your answer.  0.27. What is the ratio of the Coal rent(as % of GDP) in Lower middle income in 2004 to that in 2008?
Your response must be concise. 0.44. What is the ratio of the Coal rent(as % of GDP) of Sub-Saharan Africa (all income levels) in 2004 to that in 2008?
Offer a very short reply. 0.48. What is the ratio of the Coal rent(as % of GDP) in East Asia (developing only) in 2005 to that in 2006?
Your answer should be very brief. 0.94. What is the ratio of the Coal rent(as % of GDP) of Latin America(all income levels) in 2005 to that in 2006?
Make the answer very short. 0.67. What is the ratio of the Coal rent(as % of GDP) in Lower middle income in 2005 to that in 2006?
Provide a succinct answer. 0.96. What is the ratio of the Coal rent(as % of GDP) in Sub-Saharan Africa (all income levels) in 2005 to that in 2006?
Give a very brief answer. 1.02. What is the ratio of the Coal rent(as % of GDP) in East Asia (developing only) in 2005 to that in 2007?
Your response must be concise. 0.63. What is the ratio of the Coal rent(as % of GDP) of Latin America(all income levels) in 2005 to that in 2007?
Your answer should be compact. 0.24. What is the ratio of the Coal rent(as % of GDP) of Lower middle income in 2005 to that in 2007?
Provide a short and direct response. 0.72. What is the ratio of the Coal rent(as % of GDP) of Sub-Saharan Africa (all income levels) in 2005 to that in 2007?
Make the answer very short. 0.69. What is the ratio of the Coal rent(as % of GDP) of East Asia (developing only) in 2005 to that in 2008?
Give a very brief answer. 0.24. What is the ratio of the Coal rent(as % of GDP) of Latin America(all income levels) in 2005 to that in 2008?
Your answer should be very brief. 0.06. What is the ratio of the Coal rent(as % of GDP) in Lower middle income in 2005 to that in 2008?
Offer a terse response. 0.28. What is the ratio of the Coal rent(as % of GDP) of Sub-Saharan Africa (all income levels) in 2005 to that in 2008?
Offer a very short reply. 0.25. What is the ratio of the Coal rent(as % of GDP) of East Asia (developing only) in 2006 to that in 2007?
Your response must be concise. 0.67. What is the ratio of the Coal rent(as % of GDP) of Latin America(all income levels) in 2006 to that in 2007?
Provide a short and direct response. 0.36. What is the ratio of the Coal rent(as % of GDP) in Lower middle income in 2006 to that in 2007?
Keep it short and to the point. 0.76. What is the ratio of the Coal rent(as % of GDP) in Sub-Saharan Africa (all income levels) in 2006 to that in 2007?
Ensure brevity in your answer.  0.68. What is the ratio of the Coal rent(as % of GDP) in East Asia (developing only) in 2006 to that in 2008?
Make the answer very short. 0.26. What is the ratio of the Coal rent(as % of GDP) of Latin America(all income levels) in 2006 to that in 2008?
Provide a short and direct response. 0.09. What is the ratio of the Coal rent(as % of GDP) of Lower middle income in 2006 to that in 2008?
Offer a terse response. 0.3. What is the ratio of the Coal rent(as % of GDP) of Sub-Saharan Africa (all income levels) in 2006 to that in 2008?
Provide a succinct answer. 0.25. What is the ratio of the Coal rent(as % of GDP) of East Asia (developing only) in 2007 to that in 2008?
Give a very brief answer. 0.38. What is the ratio of the Coal rent(as % of GDP) in Latin America(all income levels) in 2007 to that in 2008?
Provide a short and direct response. 0.25. What is the ratio of the Coal rent(as % of GDP) of Lower middle income in 2007 to that in 2008?
Your response must be concise. 0.39. What is the ratio of the Coal rent(as % of GDP) of Sub-Saharan Africa (all income levels) in 2007 to that in 2008?
Provide a succinct answer. 0.37. What is the difference between the highest and the second highest Coal rent(as % of GDP) in East Asia (developing only)?
Offer a terse response. 1.98. What is the difference between the highest and the second highest Coal rent(as % of GDP) in Latin America(all income levels)?
Your response must be concise. 0.1. What is the difference between the highest and the second highest Coal rent(as % of GDP) of Lower middle income?
Give a very brief answer. 0.91. What is the difference between the highest and the second highest Coal rent(as % of GDP) in Sub-Saharan Africa (all income levels)?
Your response must be concise. 0.97. What is the difference between the highest and the lowest Coal rent(as % of GDP) in East Asia (developing only)?
Keep it short and to the point. 3.35. What is the difference between the highest and the lowest Coal rent(as % of GDP) in Latin America(all income levels)?
Your response must be concise. 0.14. What is the difference between the highest and the lowest Coal rent(as % of GDP) of Lower middle income?
Offer a very short reply. 1.37. What is the difference between the highest and the lowest Coal rent(as % of GDP) in Sub-Saharan Africa (all income levels)?
Give a very brief answer. 1.65. 